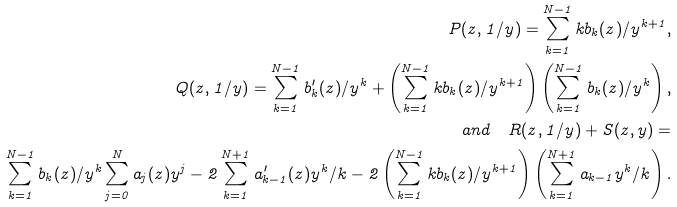Convert formula to latex. <formula><loc_0><loc_0><loc_500><loc_500>P ( z , 1 / y ) = \sum _ { k = 1 } ^ { N - 1 } k b _ { k } ( z ) / y ^ { k + 1 } , \\ Q ( z , 1 / y ) = \sum _ { k = 1 } ^ { N - 1 } b _ { k } ^ { \prime } ( z ) / y ^ { k } + \left ( \sum _ { k = 1 } ^ { N - 1 } k b _ { k } ( z ) / y ^ { k + 1 } \right ) \left ( \sum _ { k = 1 } ^ { N - 1 } b _ { k } ( z ) / y ^ { k } \right ) , \\ a n d \quad R ( z , 1 / y ) + S ( z , y ) = \\ \sum _ { k = 1 } ^ { N - 1 } b _ { k } ( z ) / y ^ { k } \sum _ { j = 0 } ^ { N } a _ { j } ( z ) y ^ { j } - 2 \sum _ { k = 1 } ^ { N + 1 } a _ { k - 1 } ^ { \prime } ( z ) y ^ { k } / k - 2 \left ( \sum _ { k = 1 } ^ { N - 1 } k b _ { k } ( z ) / y ^ { k + 1 } \right ) \left ( \sum _ { k = 1 } ^ { N + 1 } a _ { k - 1 } y ^ { k } / k \right ) .</formula> 